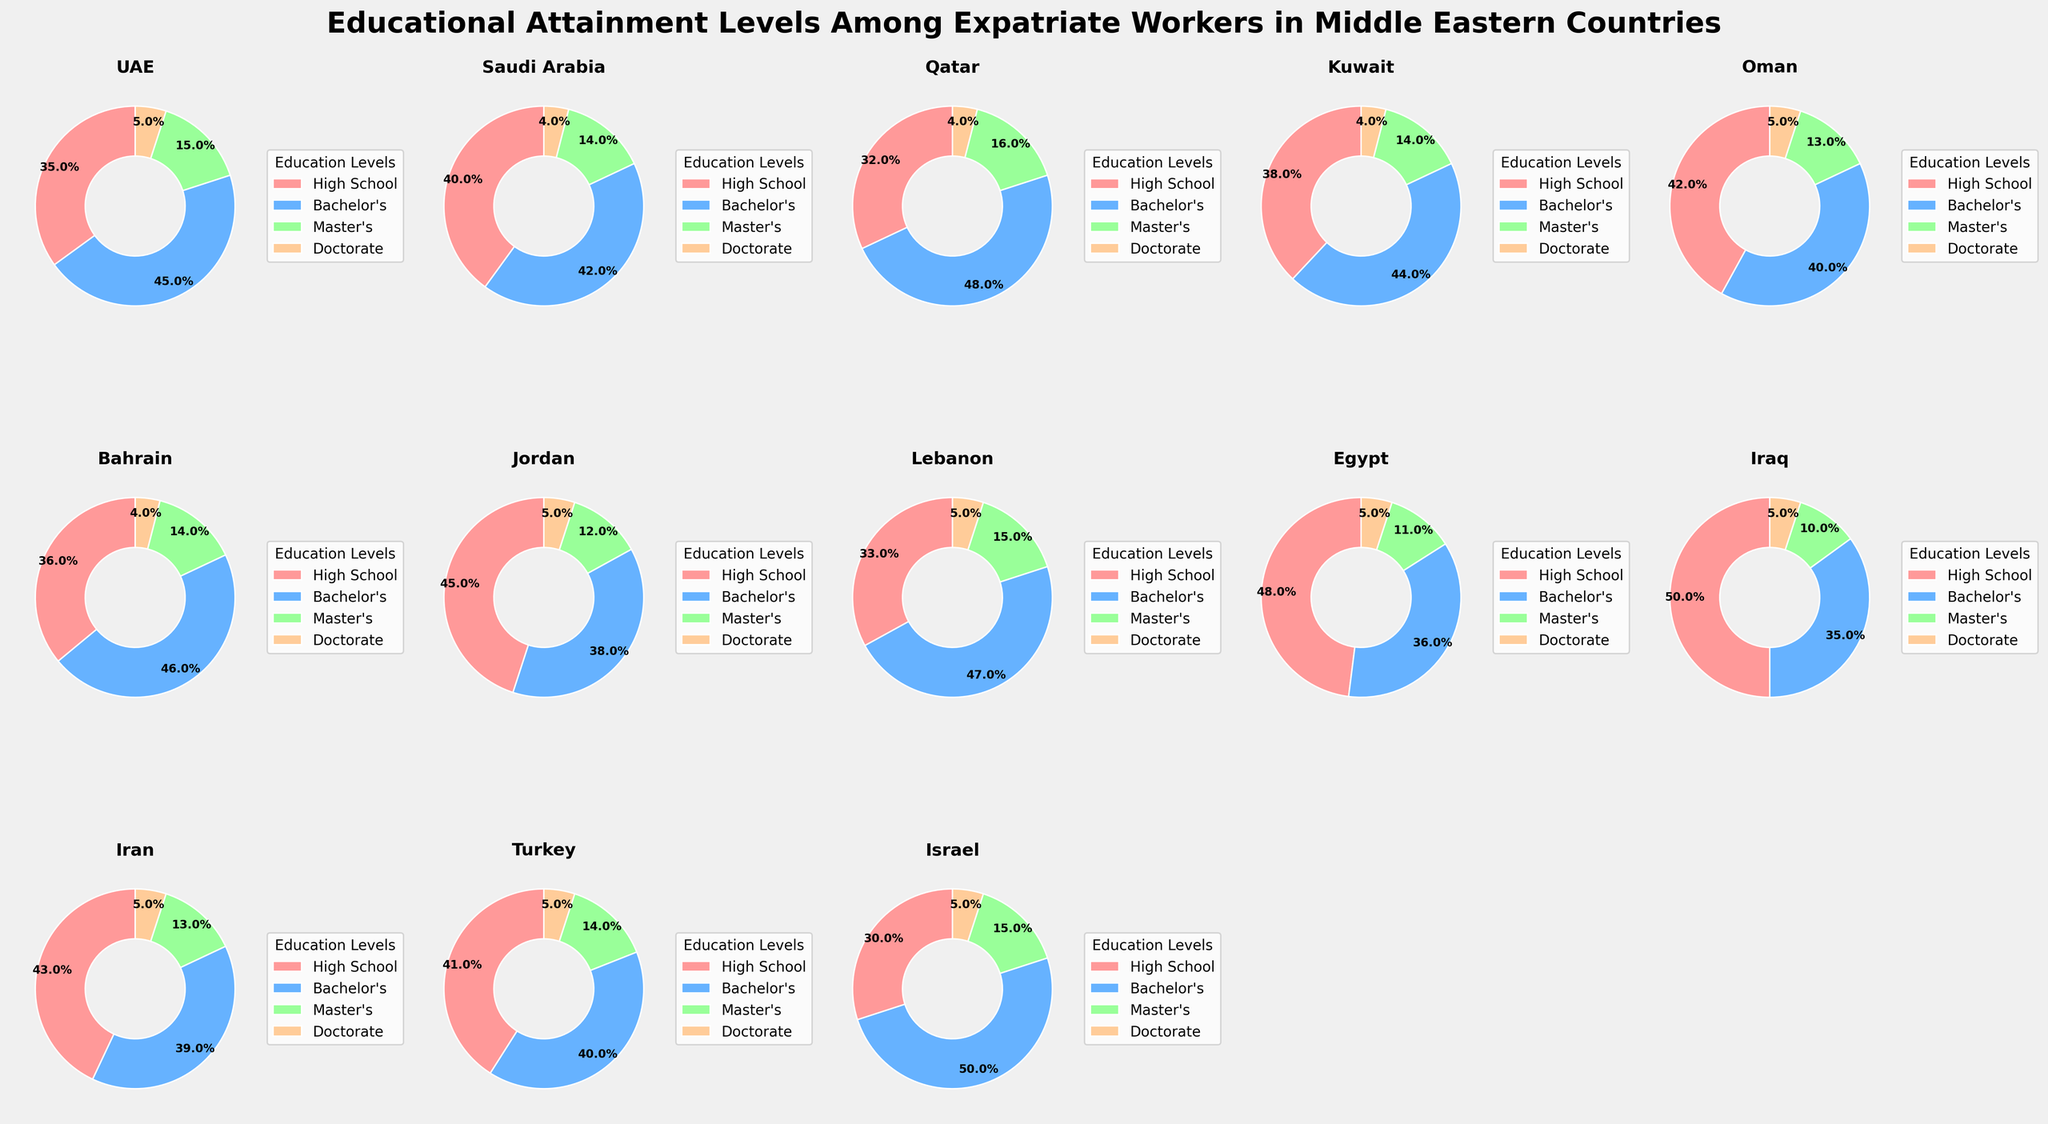What percentage of expatriate workers in Jordan have attained a Bachelor's degree? From the plot for Jordan, we see that the segment representing Bachelor's degree is labeled '38%'.
Answer: 38% Among UAE, Saudi Arabia, and Qatar, which country has the highest percentage of expatriate workers with a Master's degree? By looking at the segments representing Master's degrees for UAE, Saudi Arabia, and Qatar, we see that Qatar has 16%, which is higher than the 15% for UAE and 14% for Saudi Arabia.
Answer: Qatar What is the total percentage of expatriate workers with high school education in Iran, Turkey, and Israel? Adding the percentages from the respective segments: Iran (43%) + Turkey (41%) + Israel (30%) = 43 + 41 + 30 = 114%.
Answer: 114% Which countries have the same percentage of expatriate workers with Doctorate degrees? Doctorate percentages are equal in several countries: Saudi Arabia, Qatar, Kuwait, Bahrain, Jordan, Egypt, Iraq, Iran, and Turkey all have 4%, while UAE, Lebanon, Oman, and Israel all have 5%.
Answer: Multiple countries What is the difference in the Bachelor's degree attainment rate between Egypt and Lebanon? The Bachelor's attainment rate for Egypt is 36%, and for Lebanon, it is 47%. The difference is calculated as 47 - 36 = 11%.
Answer: 11% Which country has the highest overall proportion of expatriate workers with a Bachelor's degree and a Master's degree combined? Adding the Bachelor's and Master's percentages for each country, Israel has the highest combined value: Bachelor's (50%) + Master's (15%) = 65%.
Answer: Israel Is there any country where the percentage of expatriate workers with High School education is greater than those with Bachelor's degree? Only Egypt has a higher percentage of High School education (48%) compared to Bachelor's (36%).
Answer: Egypt Determine the average percentage of expatriate workers with Doctorate degrees across all countries in the figure. The percentages for Doctorate degrees across all countries are 5%, 4%, 4%, 4%, 5%, 4%, 5%, 5%, 5%, 5%, 5%, 5%, 5%. Summing them gives 61% and the average is 61%/13 = 4.69%.
Answer: 4.69% What is the ratio of expatriate workers with a Bachelor's degree to those with a Master's degree in Kuwait? The percentages for Bachelor's and Master's in Kuwait are 44% and 14%, respectively. The ratio is 44:14, which simplifies to approximately 3.14:1.
Answer: 3.14:1 Among the countries shown, which one has the lowest percentage of expatriate workers with a High School education? From the plot, Israel has the lowest percentage of expatriate workers with High School education at 30%.
Answer: Israel 